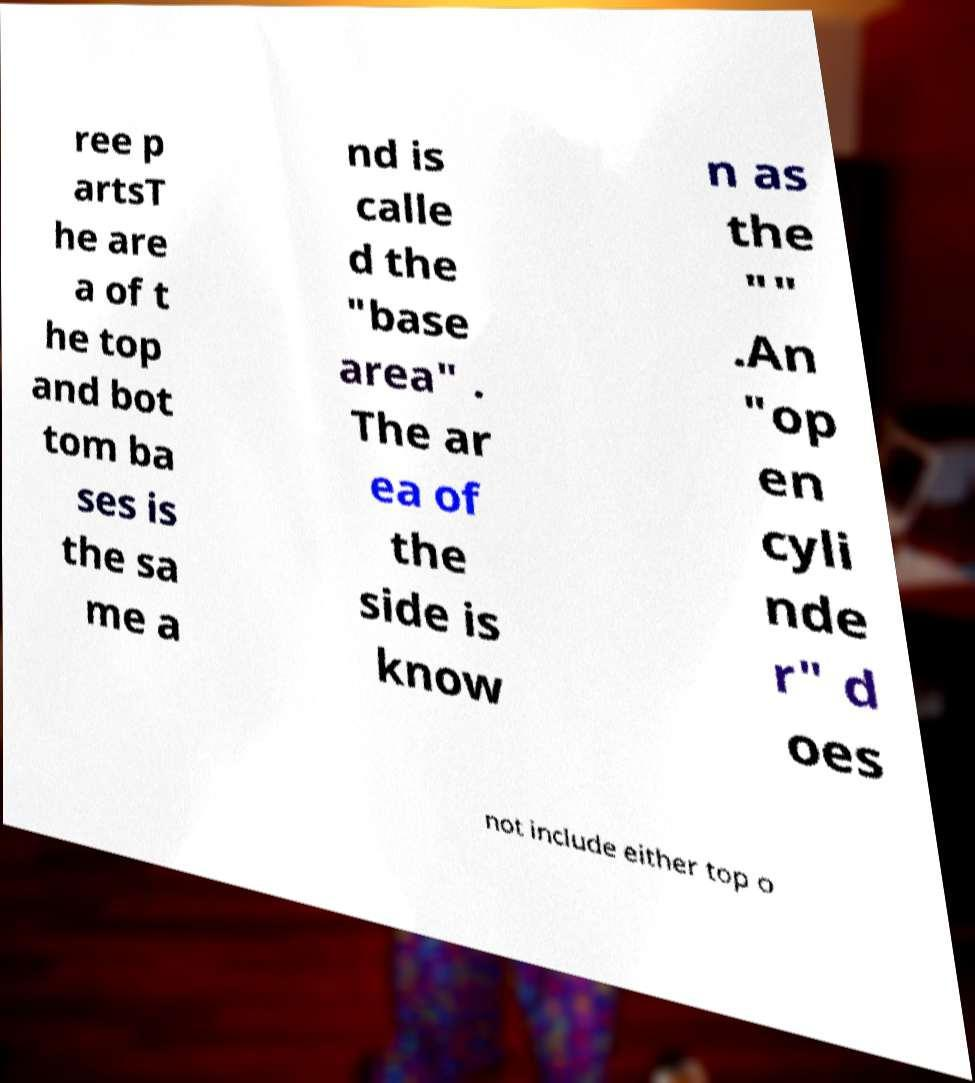Could you extract and type out the text from this image? ree p artsT he are a of t he top and bot tom ba ses is the sa me a nd is calle d the "base area" . The ar ea of the side is know n as the "" .An "op en cyli nde r" d oes not include either top o 